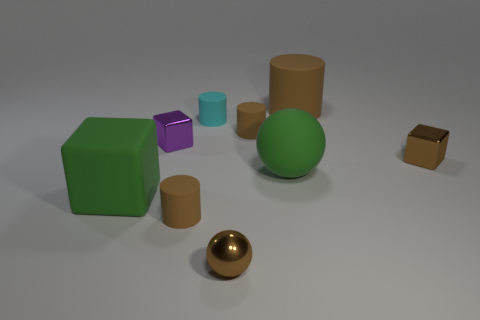Subtract all gray blocks. How many brown cylinders are left? 3 Add 1 big gray rubber cylinders. How many objects exist? 10 Subtract all cylinders. How many objects are left? 5 Subtract 0 purple balls. How many objects are left? 9 Subtract all cyan rubber cylinders. Subtract all balls. How many objects are left? 6 Add 8 big spheres. How many big spheres are left? 9 Add 2 tiny purple objects. How many tiny purple objects exist? 3 